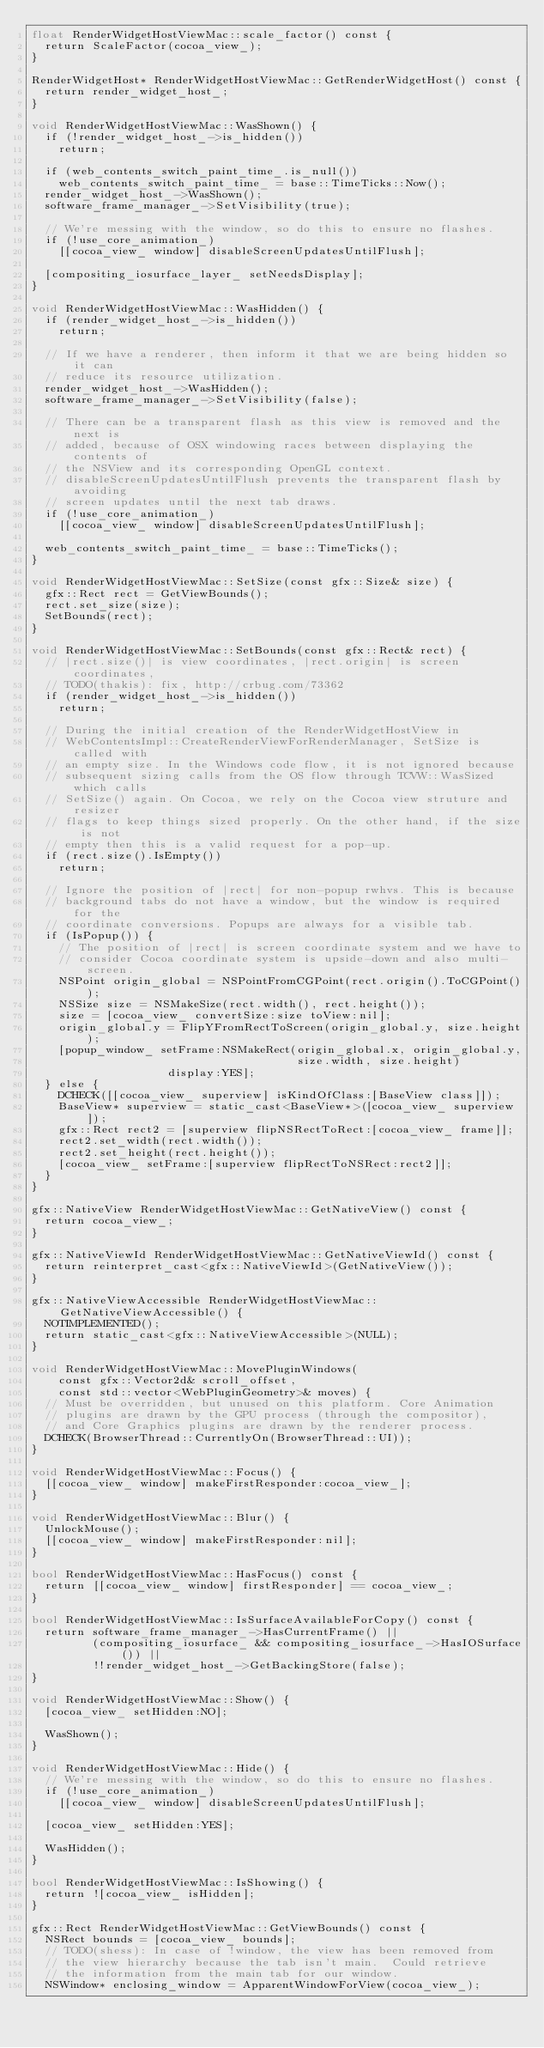<code> <loc_0><loc_0><loc_500><loc_500><_ObjectiveC_>float RenderWidgetHostViewMac::scale_factor() const {
  return ScaleFactor(cocoa_view_);
}

RenderWidgetHost* RenderWidgetHostViewMac::GetRenderWidgetHost() const {
  return render_widget_host_;
}

void RenderWidgetHostViewMac::WasShown() {
  if (!render_widget_host_->is_hidden())
    return;

  if (web_contents_switch_paint_time_.is_null())
    web_contents_switch_paint_time_ = base::TimeTicks::Now();
  render_widget_host_->WasShown();
  software_frame_manager_->SetVisibility(true);

  // We're messing with the window, so do this to ensure no flashes.
  if (!use_core_animation_)
    [[cocoa_view_ window] disableScreenUpdatesUntilFlush];

  [compositing_iosurface_layer_ setNeedsDisplay];
}

void RenderWidgetHostViewMac::WasHidden() {
  if (render_widget_host_->is_hidden())
    return;

  // If we have a renderer, then inform it that we are being hidden so it can
  // reduce its resource utilization.
  render_widget_host_->WasHidden();
  software_frame_manager_->SetVisibility(false);

  // There can be a transparent flash as this view is removed and the next is
  // added, because of OSX windowing races between displaying the contents of
  // the NSView and its corresponding OpenGL context.
  // disableScreenUpdatesUntilFlush prevents the transparent flash by avoiding
  // screen updates until the next tab draws.
  if (!use_core_animation_)
    [[cocoa_view_ window] disableScreenUpdatesUntilFlush];

  web_contents_switch_paint_time_ = base::TimeTicks();
}

void RenderWidgetHostViewMac::SetSize(const gfx::Size& size) {
  gfx::Rect rect = GetViewBounds();
  rect.set_size(size);
  SetBounds(rect);
}

void RenderWidgetHostViewMac::SetBounds(const gfx::Rect& rect) {
  // |rect.size()| is view coordinates, |rect.origin| is screen coordinates,
  // TODO(thakis): fix, http://crbug.com/73362
  if (render_widget_host_->is_hidden())
    return;

  // During the initial creation of the RenderWidgetHostView in
  // WebContentsImpl::CreateRenderViewForRenderManager, SetSize is called with
  // an empty size. In the Windows code flow, it is not ignored because
  // subsequent sizing calls from the OS flow through TCVW::WasSized which calls
  // SetSize() again. On Cocoa, we rely on the Cocoa view struture and resizer
  // flags to keep things sized properly. On the other hand, if the size is not
  // empty then this is a valid request for a pop-up.
  if (rect.size().IsEmpty())
    return;

  // Ignore the position of |rect| for non-popup rwhvs. This is because
  // background tabs do not have a window, but the window is required for the
  // coordinate conversions. Popups are always for a visible tab.
  if (IsPopup()) {
    // The position of |rect| is screen coordinate system and we have to
    // consider Cocoa coordinate system is upside-down and also multi-screen.
    NSPoint origin_global = NSPointFromCGPoint(rect.origin().ToCGPoint());
    NSSize size = NSMakeSize(rect.width(), rect.height());
    size = [cocoa_view_ convertSize:size toView:nil];
    origin_global.y = FlipYFromRectToScreen(origin_global.y, size.height);
    [popup_window_ setFrame:NSMakeRect(origin_global.x, origin_global.y,
                                       size.width, size.height)
                    display:YES];
  } else {
    DCHECK([[cocoa_view_ superview] isKindOfClass:[BaseView class]]);
    BaseView* superview = static_cast<BaseView*>([cocoa_view_ superview]);
    gfx::Rect rect2 = [superview flipNSRectToRect:[cocoa_view_ frame]];
    rect2.set_width(rect.width());
    rect2.set_height(rect.height());
    [cocoa_view_ setFrame:[superview flipRectToNSRect:rect2]];
  }
}

gfx::NativeView RenderWidgetHostViewMac::GetNativeView() const {
  return cocoa_view_;
}

gfx::NativeViewId RenderWidgetHostViewMac::GetNativeViewId() const {
  return reinterpret_cast<gfx::NativeViewId>(GetNativeView());
}

gfx::NativeViewAccessible RenderWidgetHostViewMac::GetNativeViewAccessible() {
  NOTIMPLEMENTED();
  return static_cast<gfx::NativeViewAccessible>(NULL);
}

void RenderWidgetHostViewMac::MovePluginWindows(
    const gfx::Vector2d& scroll_offset,
    const std::vector<WebPluginGeometry>& moves) {
  // Must be overridden, but unused on this platform. Core Animation
  // plugins are drawn by the GPU process (through the compositor),
  // and Core Graphics plugins are drawn by the renderer process.
  DCHECK(BrowserThread::CurrentlyOn(BrowserThread::UI));
}

void RenderWidgetHostViewMac::Focus() {
  [[cocoa_view_ window] makeFirstResponder:cocoa_view_];
}

void RenderWidgetHostViewMac::Blur() {
  UnlockMouse();
  [[cocoa_view_ window] makeFirstResponder:nil];
}

bool RenderWidgetHostViewMac::HasFocus() const {
  return [[cocoa_view_ window] firstResponder] == cocoa_view_;
}

bool RenderWidgetHostViewMac::IsSurfaceAvailableForCopy() const {
  return software_frame_manager_->HasCurrentFrame() ||
         (compositing_iosurface_ && compositing_iosurface_->HasIOSurface()) ||
         !!render_widget_host_->GetBackingStore(false);
}

void RenderWidgetHostViewMac::Show() {
  [cocoa_view_ setHidden:NO];

  WasShown();
}

void RenderWidgetHostViewMac::Hide() {
  // We're messing with the window, so do this to ensure no flashes.
  if (!use_core_animation_)
    [[cocoa_view_ window] disableScreenUpdatesUntilFlush];

  [cocoa_view_ setHidden:YES];

  WasHidden();
}

bool RenderWidgetHostViewMac::IsShowing() {
  return ![cocoa_view_ isHidden];
}

gfx::Rect RenderWidgetHostViewMac::GetViewBounds() const {
  NSRect bounds = [cocoa_view_ bounds];
  // TODO(shess): In case of !window, the view has been removed from
  // the view hierarchy because the tab isn't main.  Could retrieve
  // the information from the main tab for our window.
  NSWindow* enclosing_window = ApparentWindowForView(cocoa_view_);</code> 